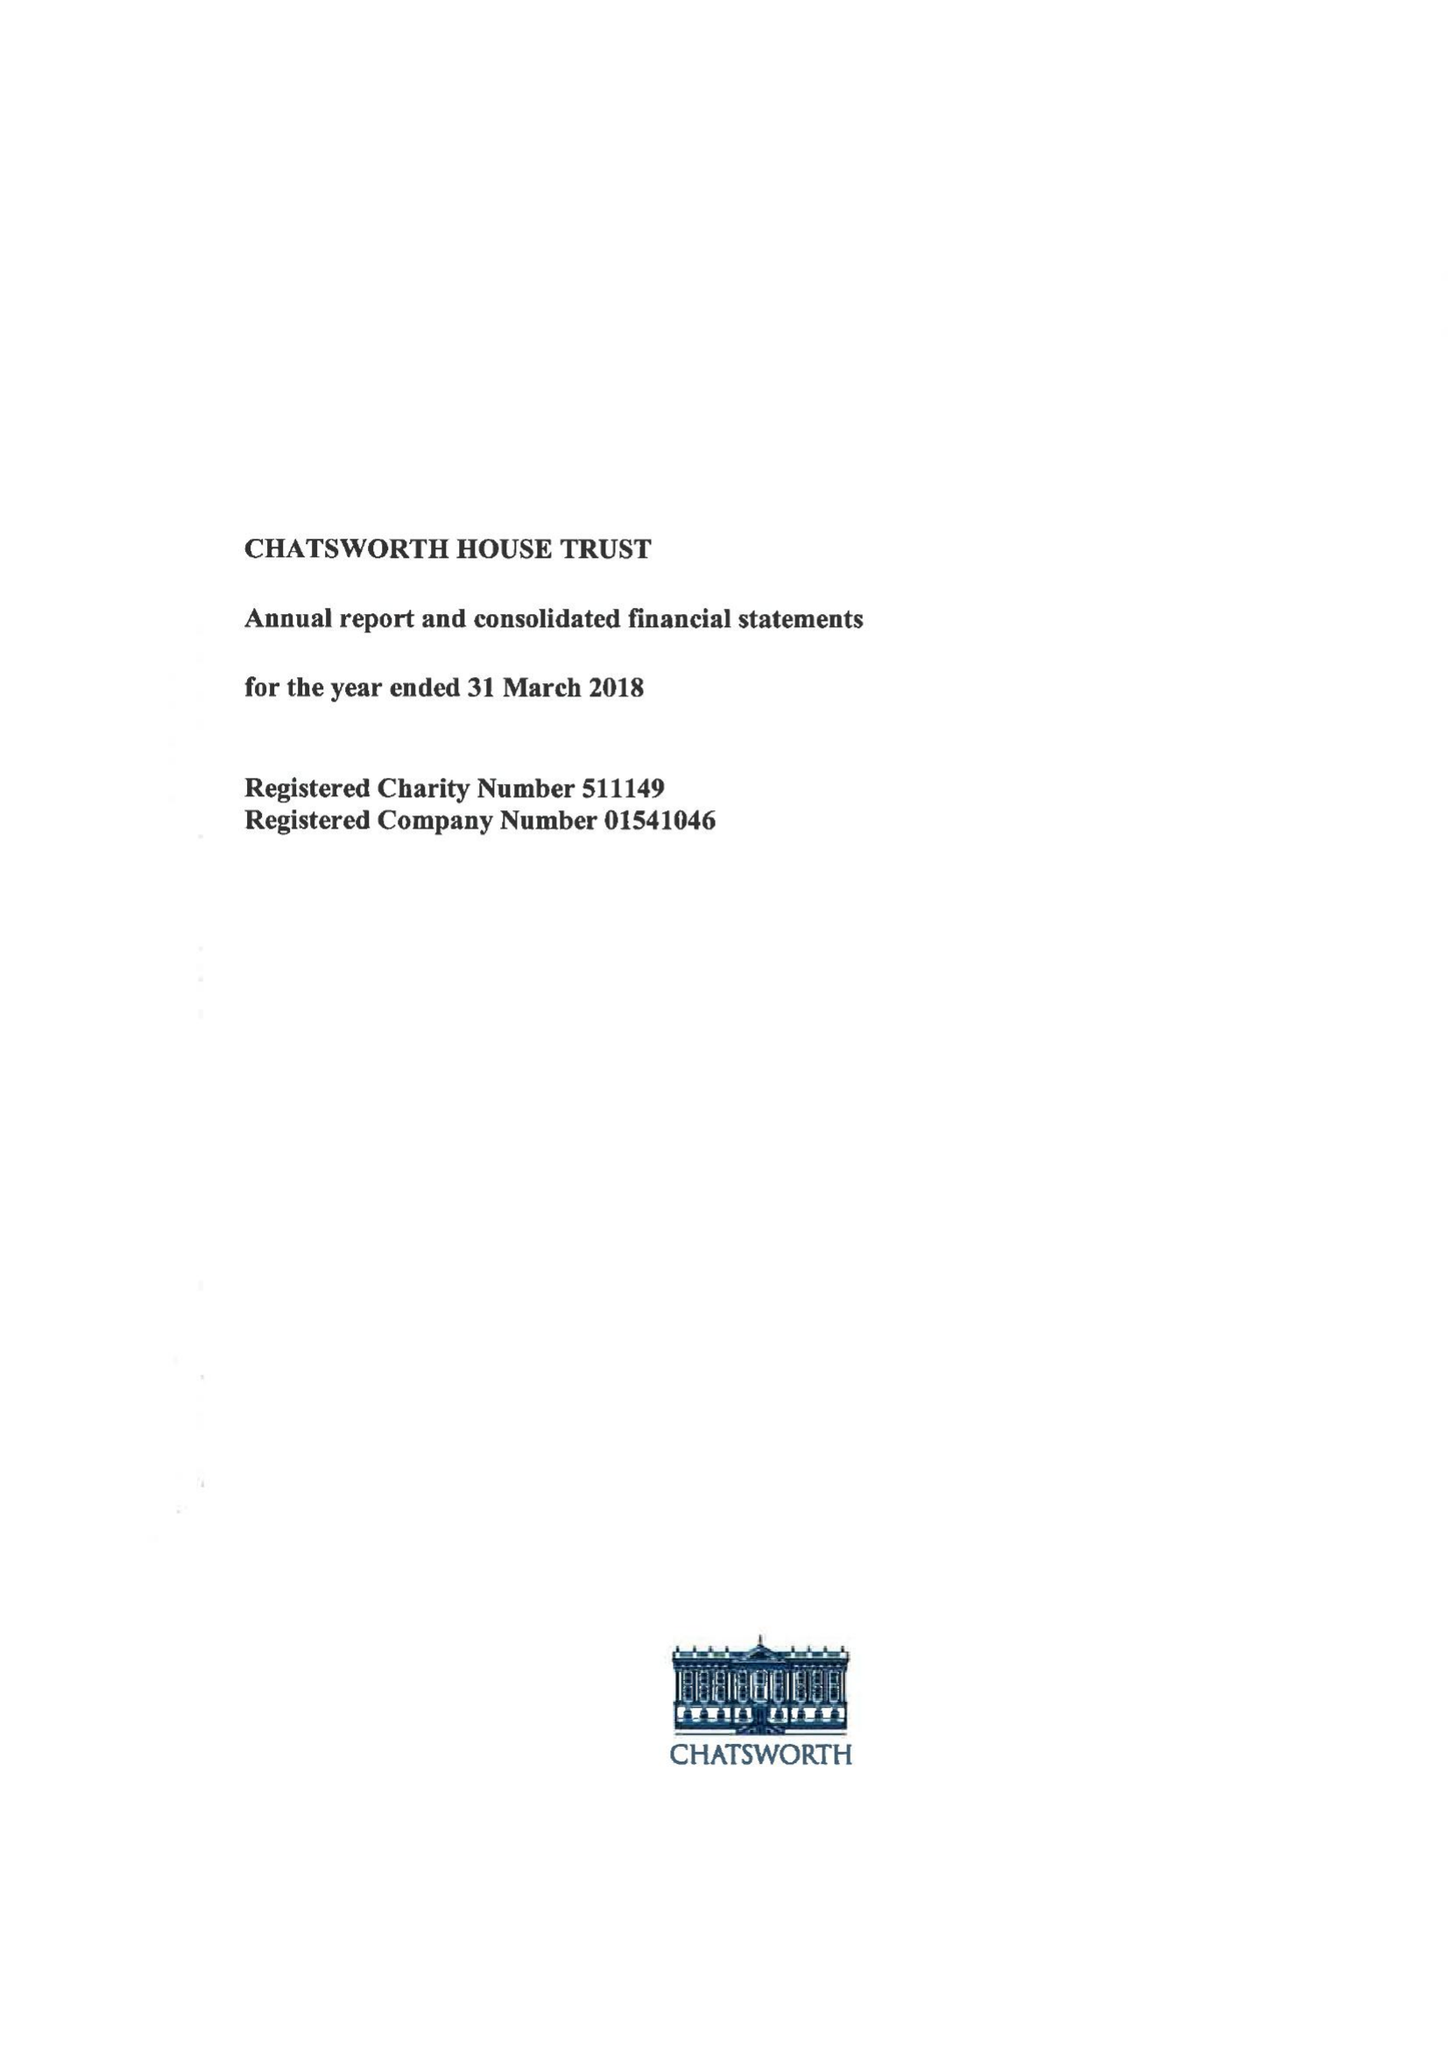What is the value for the address__postcode?
Answer the question using a single word or phrase. DE45 1PJ 